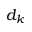<formula> <loc_0><loc_0><loc_500><loc_500>d _ { k }</formula> 